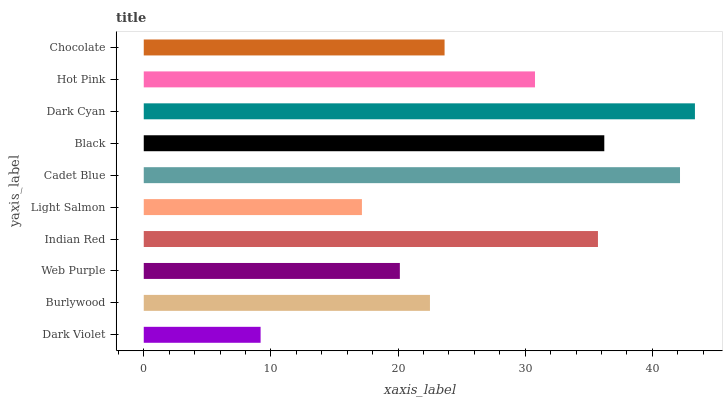Is Dark Violet the minimum?
Answer yes or no. Yes. Is Dark Cyan the maximum?
Answer yes or no. Yes. Is Burlywood the minimum?
Answer yes or no. No. Is Burlywood the maximum?
Answer yes or no. No. Is Burlywood greater than Dark Violet?
Answer yes or no. Yes. Is Dark Violet less than Burlywood?
Answer yes or no. Yes. Is Dark Violet greater than Burlywood?
Answer yes or no. No. Is Burlywood less than Dark Violet?
Answer yes or no. No. Is Hot Pink the high median?
Answer yes or no. Yes. Is Chocolate the low median?
Answer yes or no. Yes. Is Light Salmon the high median?
Answer yes or no. No. Is Cadet Blue the low median?
Answer yes or no. No. 